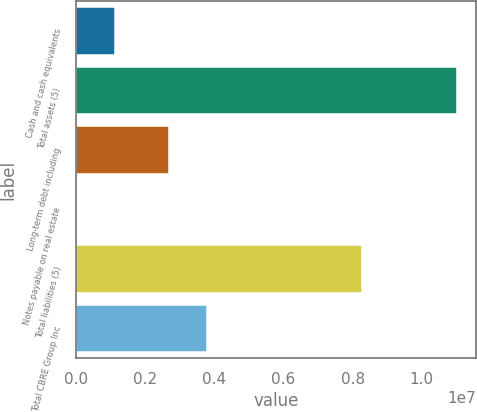<chart> <loc_0><loc_0><loc_500><loc_500><bar_chart><fcel>Cash and cash equivalents<fcel>Total assets (5)<fcel>Long-term debt including<fcel>Notes payable on real estate<fcel>Total liabilities (5)<fcel>Total CBRE Group Inc<nl><fcel>1.13623e+06<fcel>1.10179e+07<fcel>2.67954e+06<fcel>38258<fcel>8.25887e+06<fcel>3.77751e+06<nl></chart> 